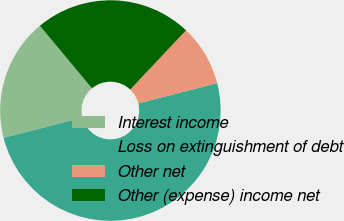Convert chart. <chart><loc_0><loc_0><loc_500><loc_500><pie_chart><fcel>Interest income<fcel>Loss on extinguishment of debt<fcel>Other net<fcel>Other (expense) income net<nl><fcel>17.95%<fcel>50.0%<fcel>8.97%<fcel>23.08%<nl></chart> 